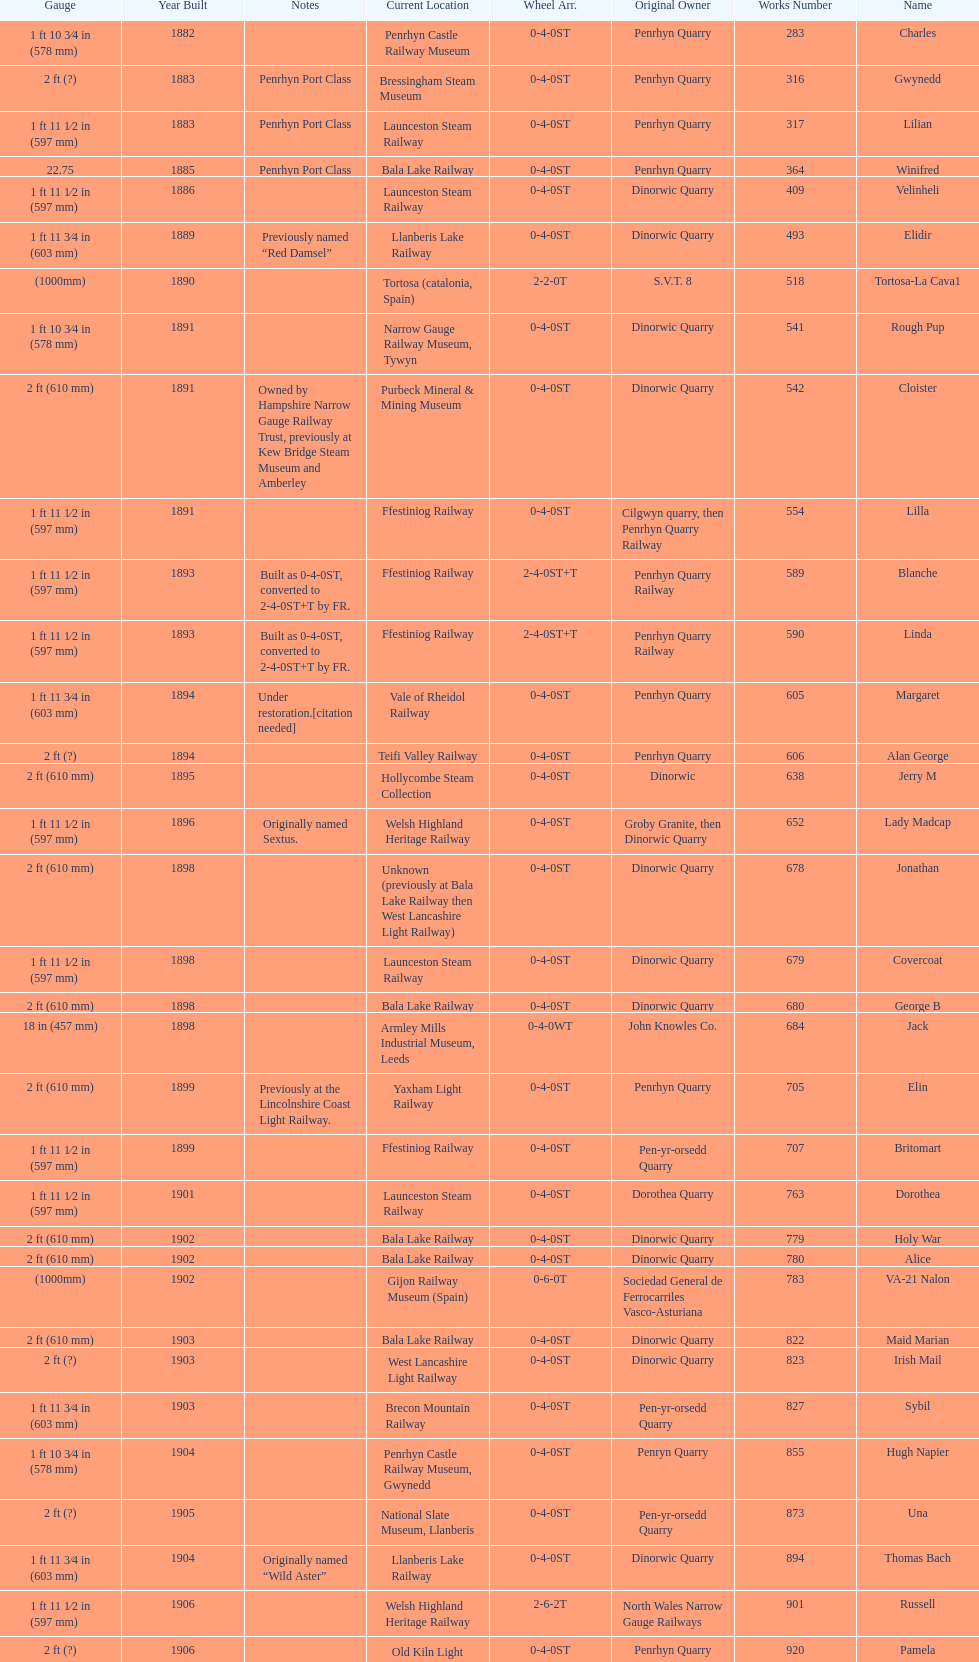What is the difference in gauge between works numbers 541 and 542? 32 mm. 